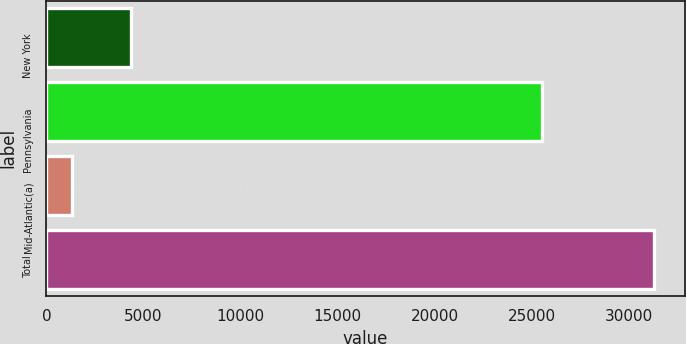Convert chart. <chart><loc_0><loc_0><loc_500><loc_500><bar_chart><fcel>New York<fcel>Pennsylvania<fcel>Mid-Atlantic(a)<fcel>Total<nl><fcel>4340.9<fcel>25533<fcel>1344<fcel>31313<nl></chart> 